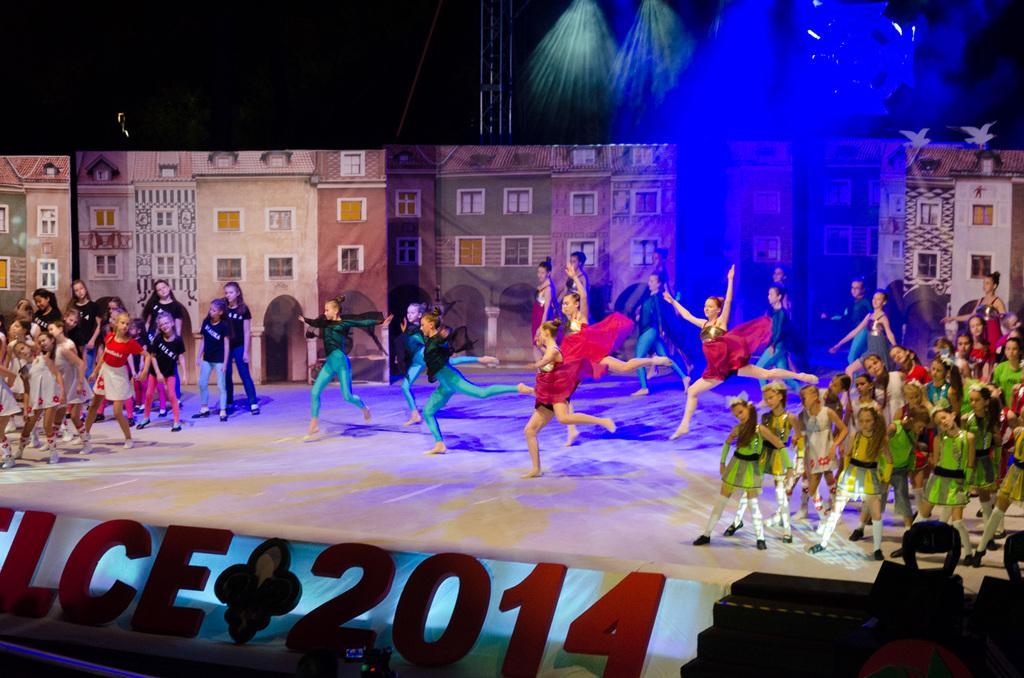In one or two sentences, can you explain what this image depicts? In this image I can see boards, stage, steps, people, focusing lights, beam, buildings and objects. 